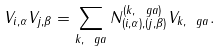<formula> <loc_0><loc_0><loc_500><loc_500>V _ { i , \alpha } V _ { j , \beta } = \sum _ { k , \ g a } N _ { ( i , \alpha ) , ( j , \beta ) } ^ { ( k , \ g a ) } V _ { k , \ g a } .</formula> 